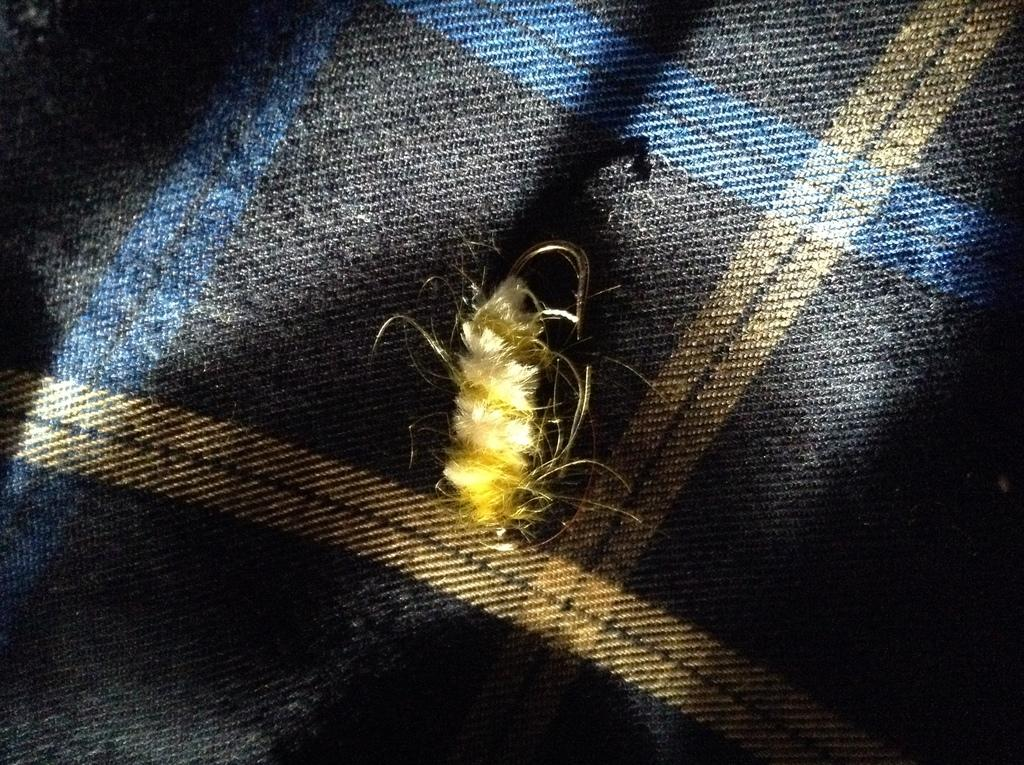What is present on the cloth in the image? An insect is crawling on the cloth in the image. What is the source of illumination for the cloth? There is sunlight falling on the cloth in the image. What is the primary material of the object on the cloth? The cloth is the primary material of the object in the image. What type of jar is visible on the cloth in the image? There is no jar present on the cloth in the image. What emotion is the insect expressing while crawling on the cloth? The insect's emotions cannot be determined from the image, as insects do not express emotions in the same way as humans. 